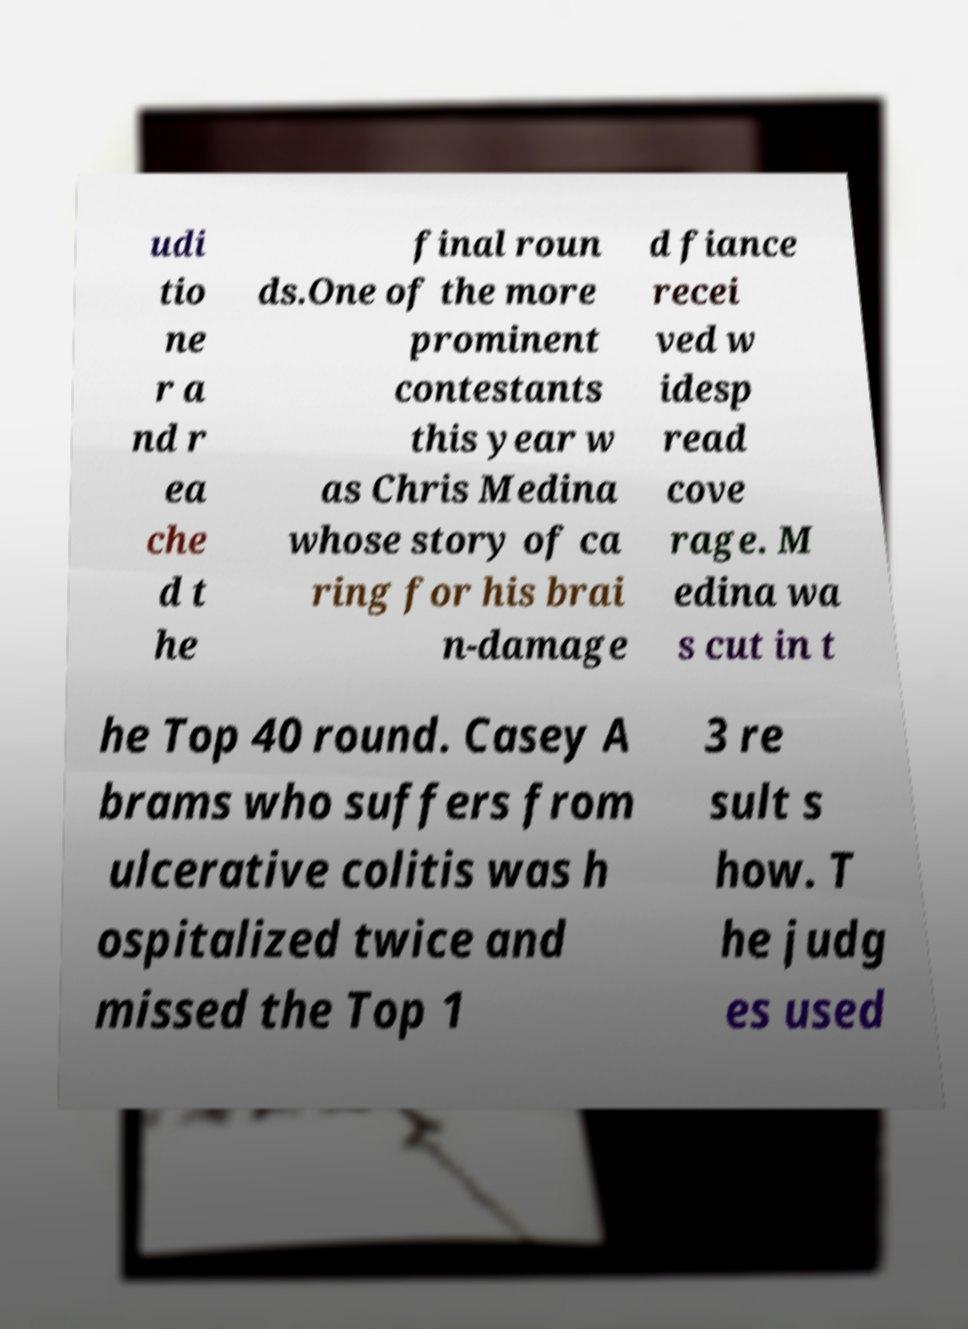Could you assist in decoding the text presented in this image and type it out clearly? udi tio ne r a nd r ea che d t he final roun ds.One of the more prominent contestants this year w as Chris Medina whose story of ca ring for his brai n-damage d fiance recei ved w idesp read cove rage. M edina wa s cut in t he Top 40 round. Casey A brams who suffers from ulcerative colitis was h ospitalized twice and missed the Top 1 3 re sult s how. T he judg es used 